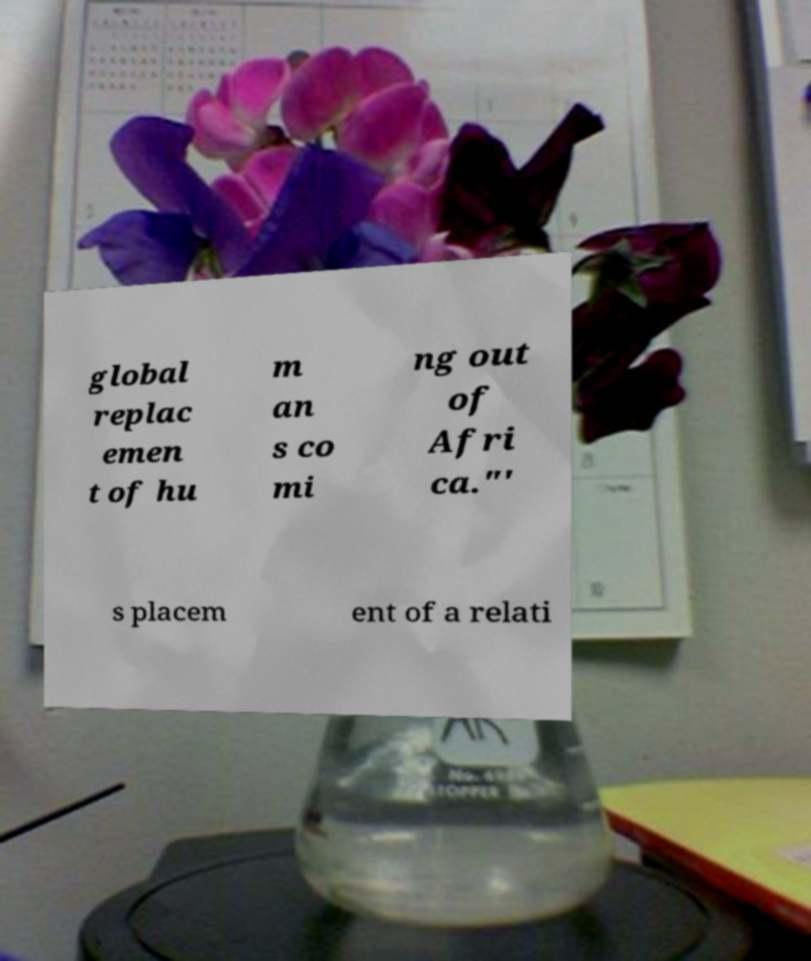There's text embedded in this image that I need extracted. Can you transcribe it verbatim? global replac emen t of hu m an s co mi ng out of Afri ca."' s placem ent of a relati 